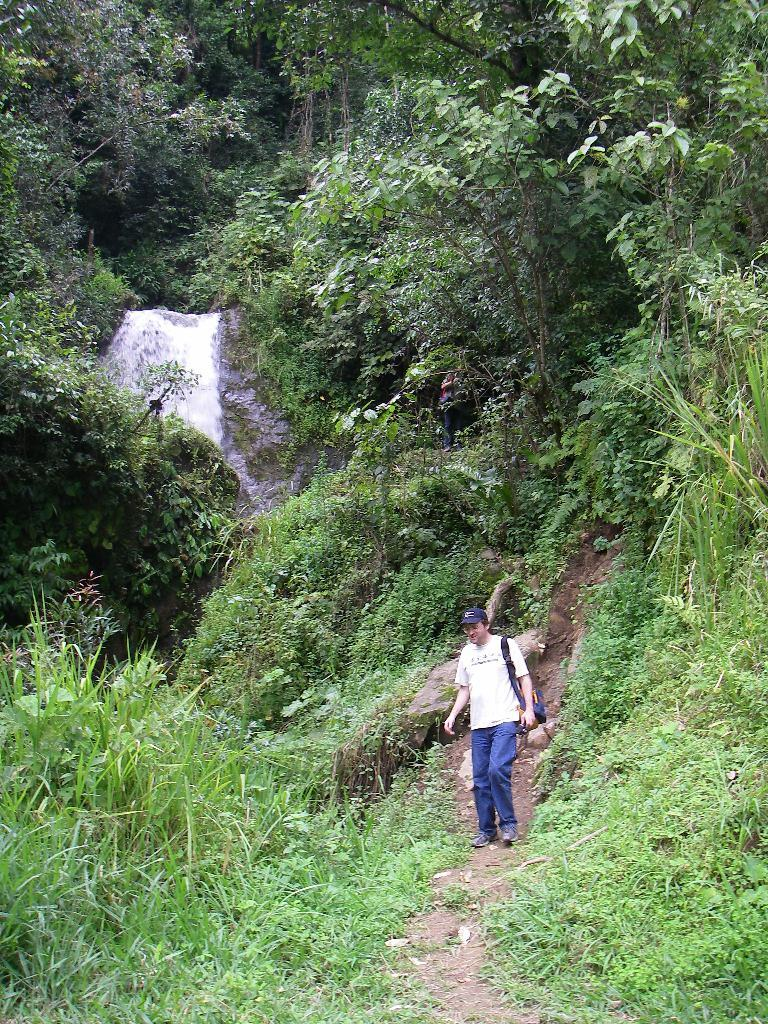What types of vegetation can be seen in the foreground of the picture? There are shrubs, grass, and plants in the foreground of the picture. What is the person in the foreground of the picture doing? There is a person walking in the foreground of the picture. What can be seen in the center of the picture? There are trees and plants in the center of the picture. What is visible at the top of the picture? There are trees at the top of the picture. Reasoning: Let's think step by step by step in order to produce the conversation. We start by identifying the types of vegetation in the foreground, which include shrubs, grass, and plants. Then, we describe the action of the person in the foreground, who is walking. Next, we mention the vegetation in the center of the picture, which consists of trees and plants. Finally, we note the presence of trees at the top of the picture. Absurd Question/Answer: What type of hands can be seen holding a piece of zinc in the image? There are no hands or zinc present in the image. How many tramps are visible in the image? There are no tramps visible in the image. 